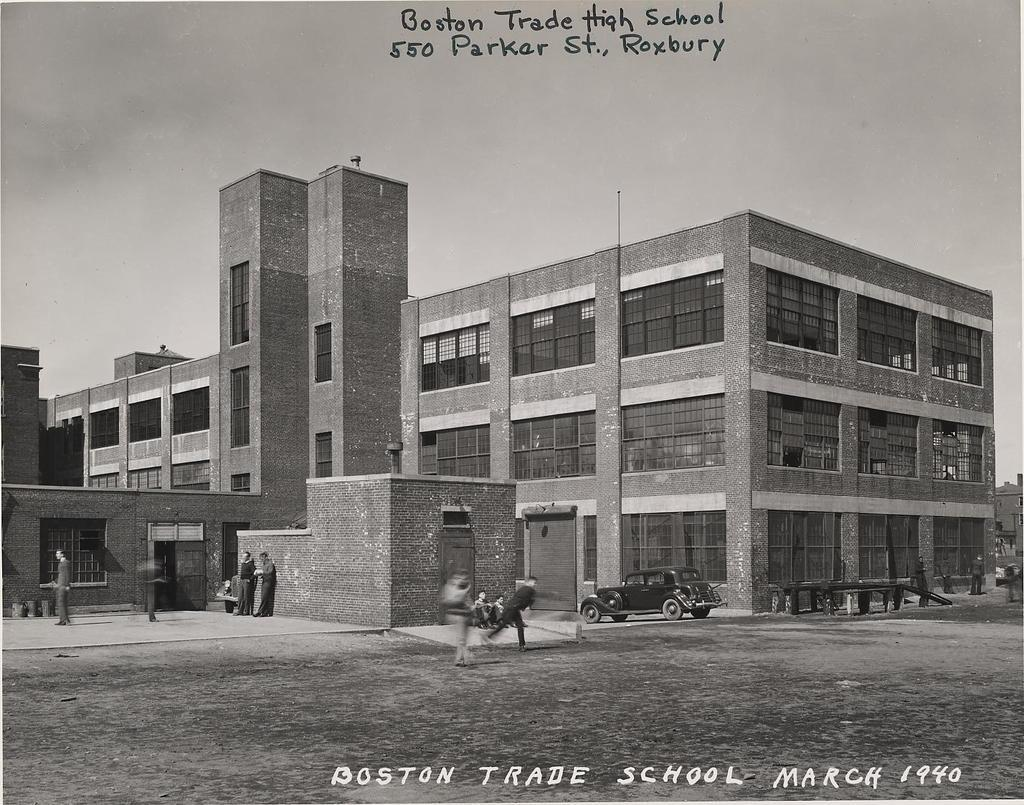What type of building is located on the left side of the image? There is a high school on the left side of the image. What can be seen in the middle of the image? There are people in the middle of the image. What is visible in the background of the image? The background of the image is the sky. How many sheep are visible in the image? There are no sheep present in the image. What type of ground is visible in the image? The image does not show any ground; it only shows the high school, people, and the sky. 